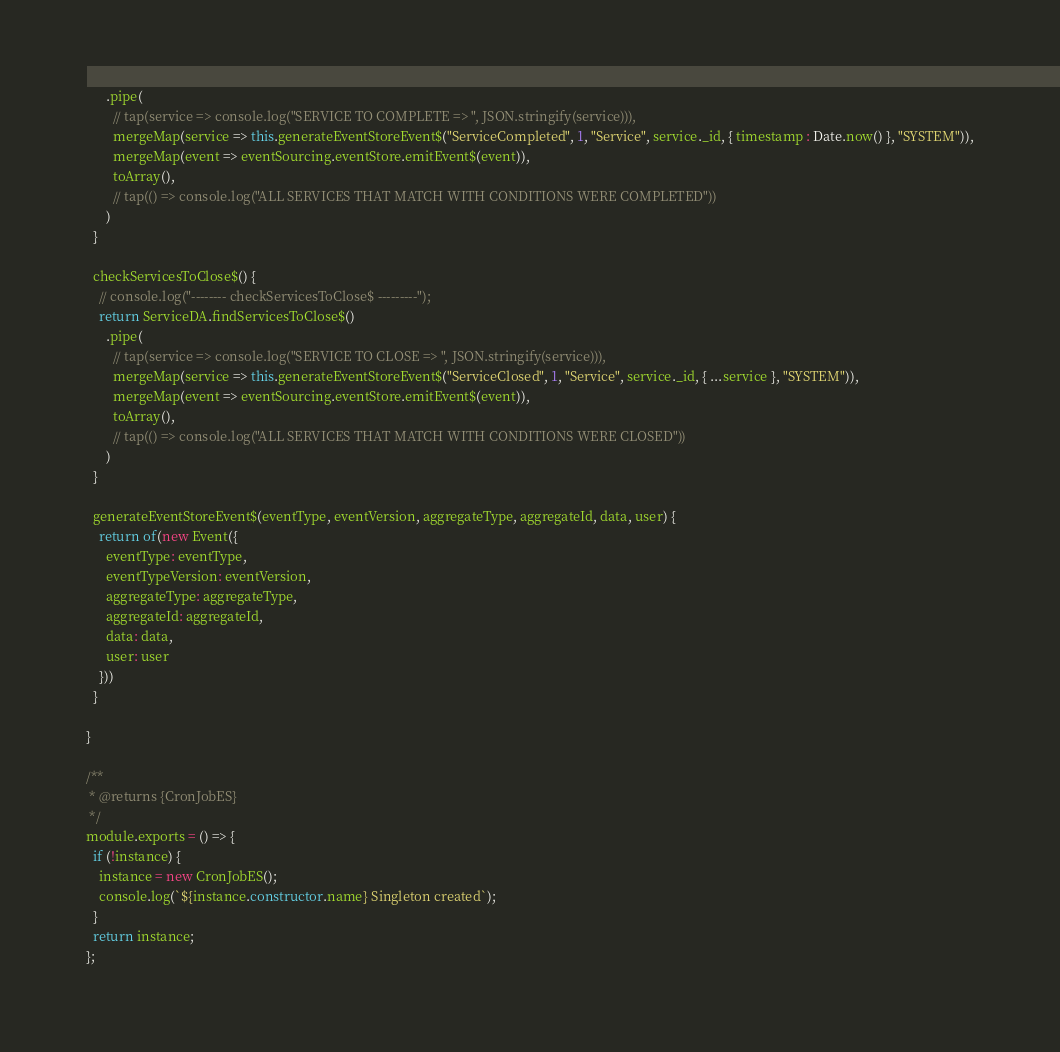Convert code to text. <code><loc_0><loc_0><loc_500><loc_500><_JavaScript_>      .pipe(
        // tap(service => console.log("SERVICE TO COMPLETE => ", JSON.stringify(service))),
        mergeMap(service => this.generateEventStoreEvent$("ServiceCompleted", 1, "Service", service._id, { timestamp : Date.now() }, "SYSTEM")),
        mergeMap(event => eventSourcing.eventStore.emitEvent$(event)),
        toArray(),
        // tap(() => console.log("ALL SERVICES THAT MATCH WITH CONDITIONS WERE COMPLETED"))
      )
  }

  checkServicesToClose$() {
    // console.log("-------- checkServicesToClose$ ---------");
    return ServiceDA.findServicesToClose$()
      .pipe(
        // tap(service => console.log("SERVICE TO CLOSE => ", JSON.stringify(service))),
        mergeMap(service => this.generateEventStoreEvent$("ServiceClosed", 1, "Service", service._id, { ...service }, "SYSTEM")),
        mergeMap(event => eventSourcing.eventStore.emitEvent$(event)),
        toArray(),
        // tap(() => console.log("ALL SERVICES THAT MATCH WITH CONDITIONS WERE CLOSED"))
      )
  }

  generateEventStoreEvent$(eventType, eventVersion, aggregateType, aggregateId, data, user) {
    return of(new Event({
      eventType: eventType,
      eventTypeVersion: eventVersion,
      aggregateType: aggregateType,
      aggregateId: aggregateId,
      data: data,
      user: user
    }))
  }

}

/**
 * @returns {CronJobES}
 */
module.exports = () => {
  if (!instance) {
    instance = new CronJobES();
    console.log(`${instance.constructor.name} Singleton created`);
  }
  return instance;
};
</code> 